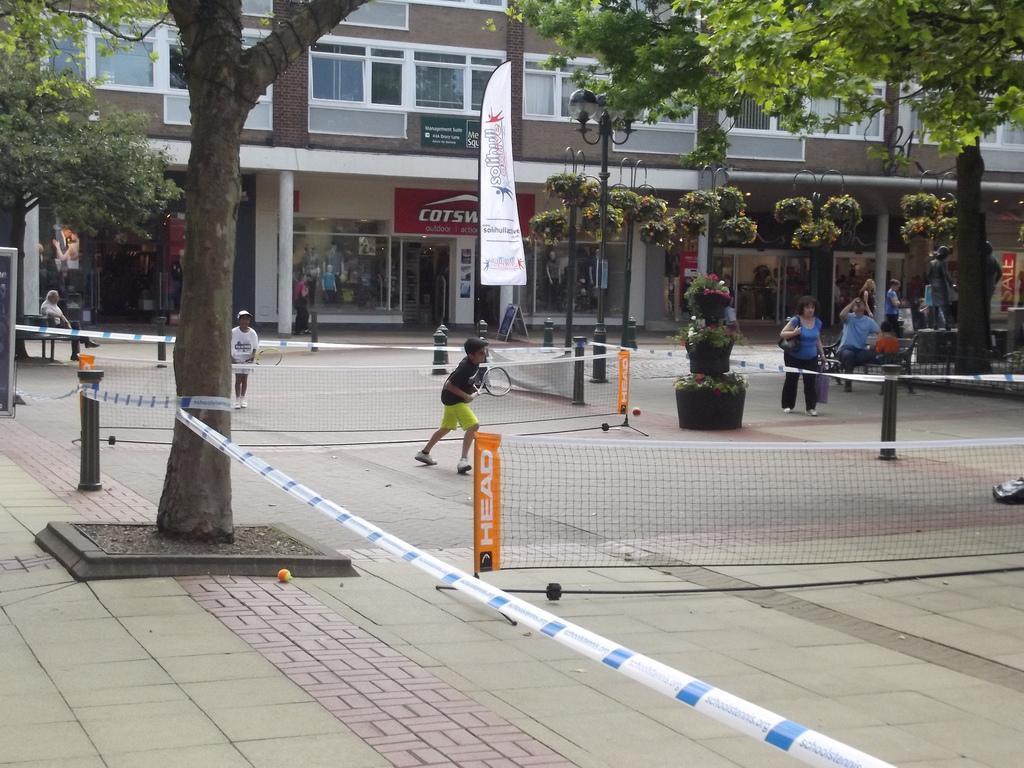How many nets are visible?
Give a very brief answer. 2. How many flower pots are stacked?
Give a very brief answer. 3. How many posts are holding decorative plants?
Give a very brief answer. 4. 